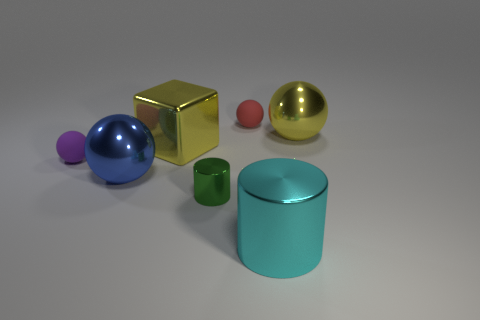Is the number of big cyan cylinders greater than the number of yellow matte blocks?
Provide a succinct answer. Yes. Are there any other things that are the same color as the tiny cylinder?
Your answer should be very brief. No. What number of other objects are the same size as the purple matte thing?
Your answer should be compact. 2. There is a purple object in front of the shiny ball that is to the right of the small ball behind the large yellow block; what is it made of?
Ensure brevity in your answer.  Rubber. Are the purple sphere and the big sphere right of the red rubber object made of the same material?
Give a very brief answer. No. Is the number of big metal balls left of the cyan metallic cylinder less than the number of red matte things that are behind the green shiny cylinder?
Your answer should be very brief. No. How many small green cylinders are the same material as the tiny purple object?
Offer a very short reply. 0. There is a tiny sphere on the right side of the sphere that is left of the large blue sphere; is there a large object behind it?
Give a very brief answer. No. How many balls are either big shiny things or large purple matte things?
Offer a very short reply. 2. There is a green metallic object; is its shape the same as the yellow object that is on the right side of the red object?
Provide a succinct answer. No. 